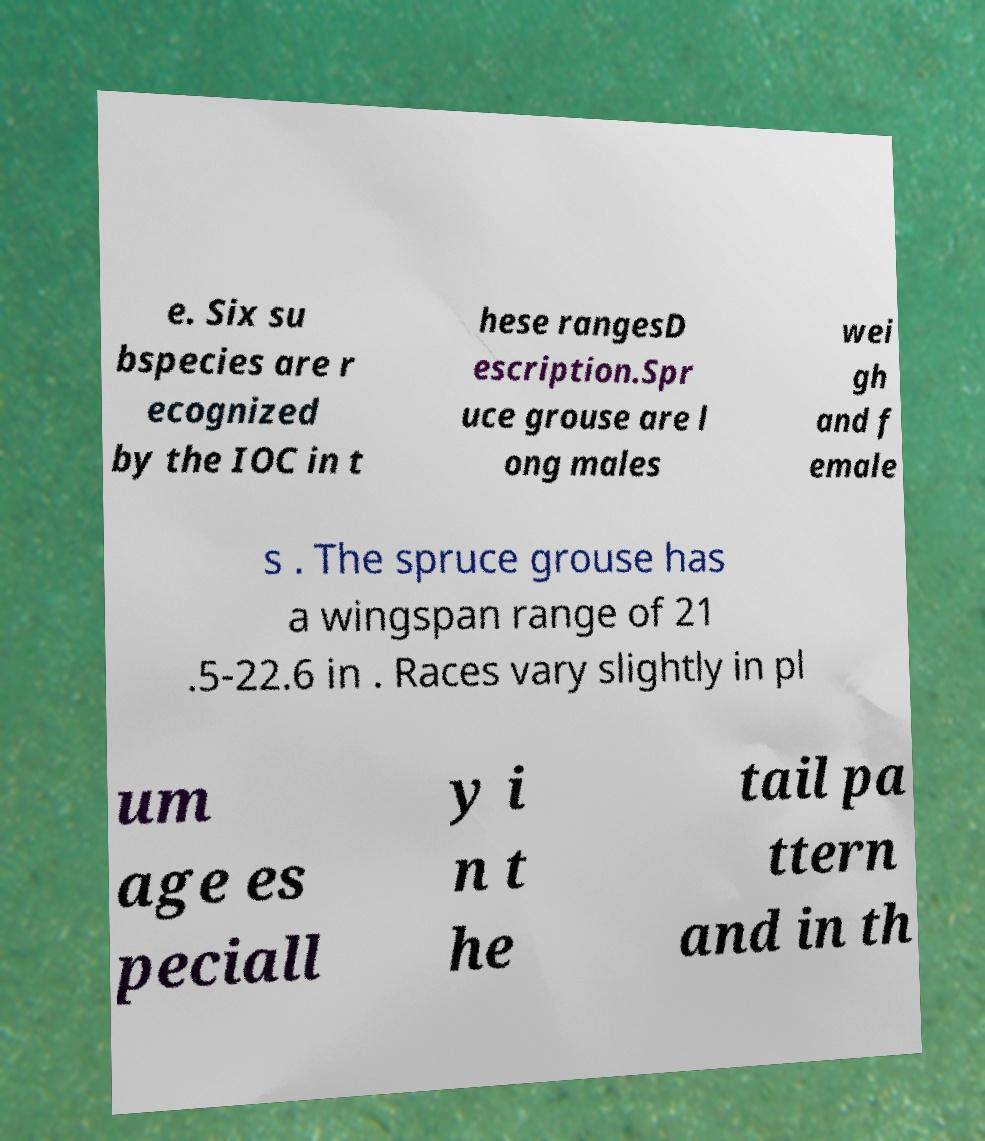Could you extract and type out the text from this image? e. Six su bspecies are r ecognized by the IOC in t hese rangesD escription.Spr uce grouse are l ong males wei gh and f emale s . The spruce grouse has a wingspan range of 21 .5-22.6 in . Races vary slightly in pl um age es peciall y i n t he tail pa ttern and in th 